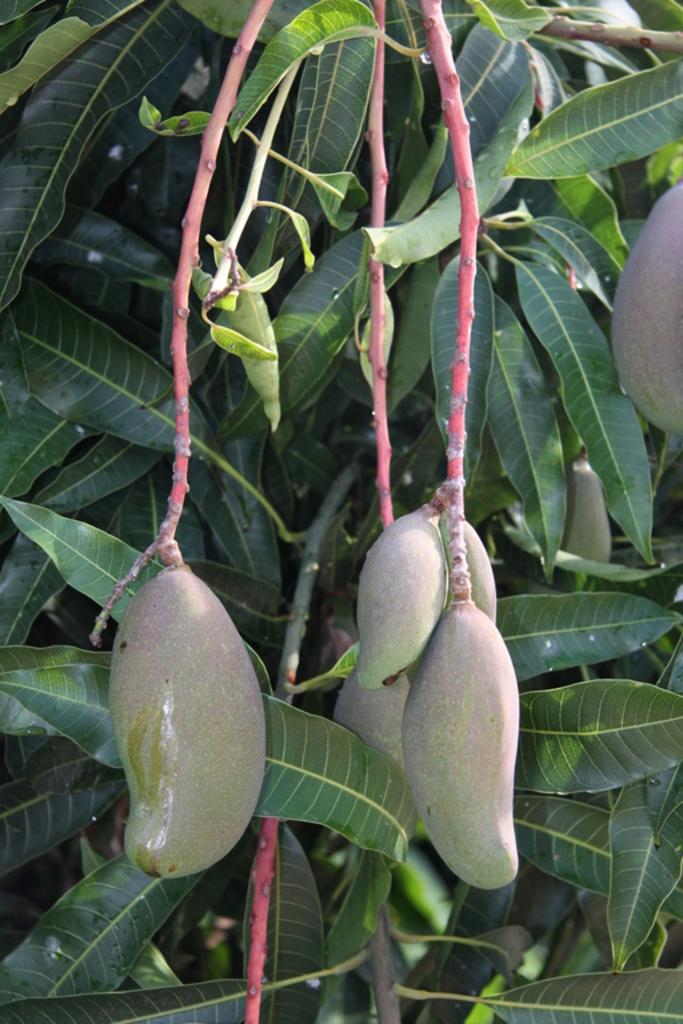What type of fruit is present in the image? There are mangoes in the image. What else is visible in the image besides the mangoes? There are mango leaves in the image. What type of pain can be seen in the image? There is no pain present in the image; it features mangoes and mango leaves. What type of bubble can be seen in the image? There is no bubble present in the image; it features mangoes and mango leaves. 